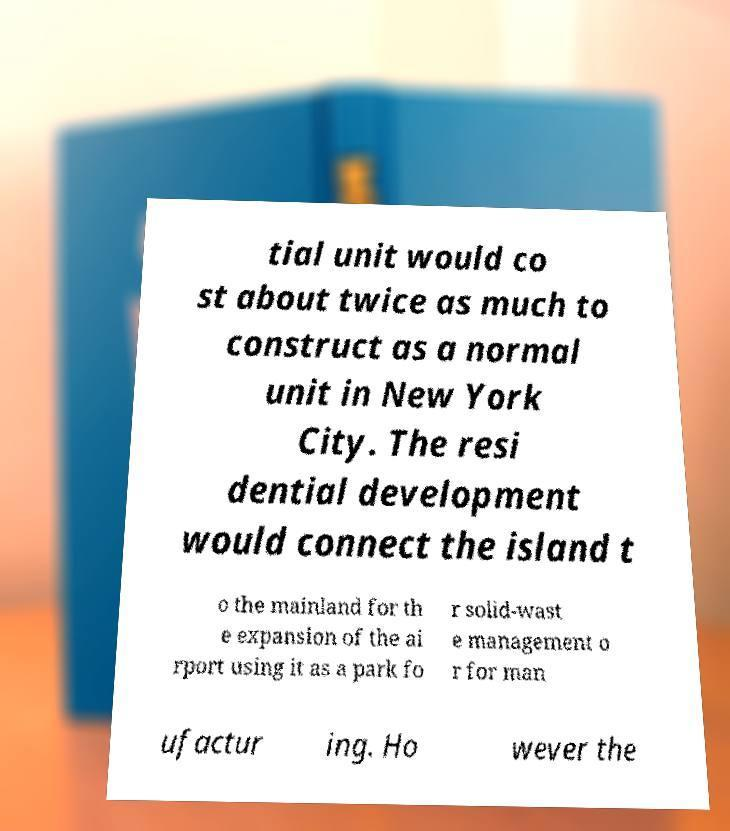There's text embedded in this image that I need extracted. Can you transcribe it verbatim? tial unit would co st about twice as much to construct as a normal unit in New York City. The resi dential development would connect the island t o the mainland for th e expansion of the ai rport using it as a park fo r solid-wast e management o r for man ufactur ing. Ho wever the 